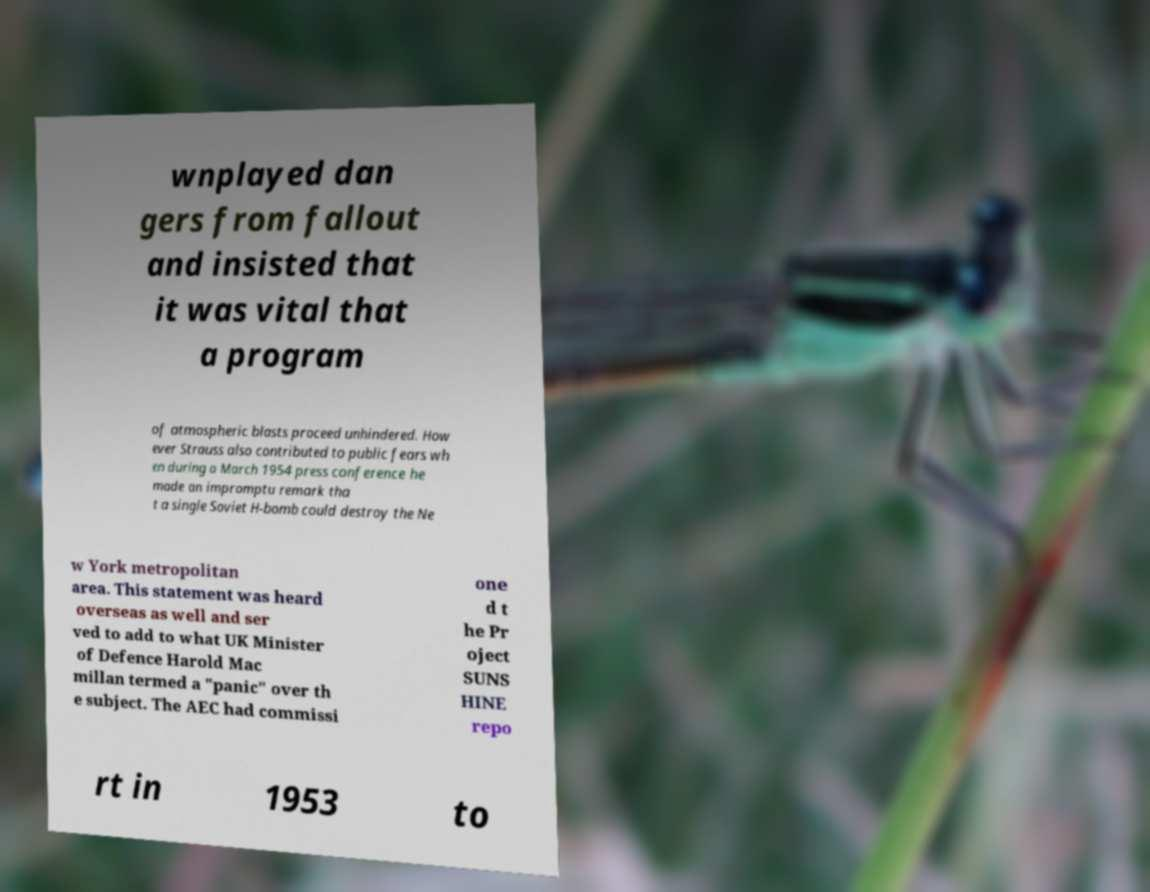For documentation purposes, I need the text within this image transcribed. Could you provide that? wnplayed dan gers from fallout and insisted that it was vital that a program of atmospheric blasts proceed unhindered. How ever Strauss also contributed to public fears wh en during a March 1954 press conference he made an impromptu remark tha t a single Soviet H-bomb could destroy the Ne w York metropolitan area. This statement was heard overseas as well and ser ved to add to what UK Minister of Defence Harold Mac millan termed a "panic" over th e subject. The AEC had commissi one d t he Pr oject SUNS HINE repo rt in 1953 to 